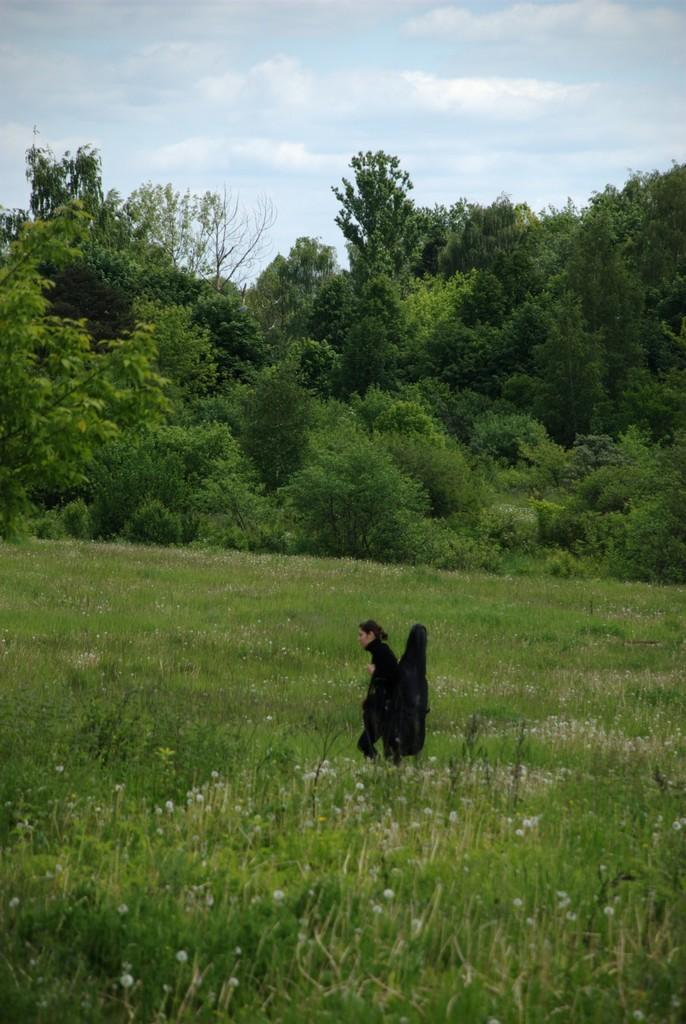Who is present in the image? There is a lady in the image. What is the lady holding in the image? The lady is holding a bag. What is the setting of the image? The lady is walking through plants. What can be seen in the background of the image? There are trees and the sky visible in the background of the image. What type of ship can be seen in the image? There is no ship present in the image. How many pets are visible in the image? There are no pets visible in the image. 